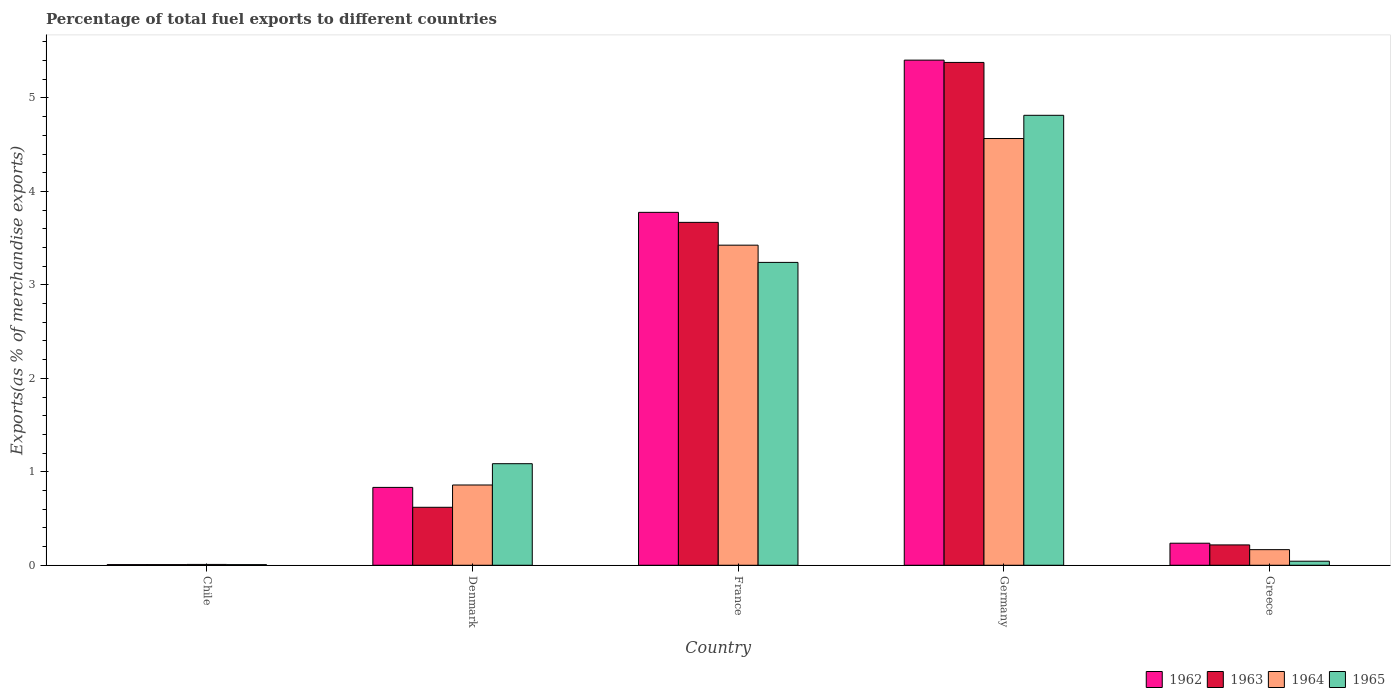Are the number of bars per tick equal to the number of legend labels?
Keep it short and to the point. Yes. Are the number of bars on each tick of the X-axis equal?
Your answer should be compact. Yes. How many bars are there on the 4th tick from the left?
Provide a short and direct response. 4. In how many cases, is the number of bars for a given country not equal to the number of legend labels?
Offer a very short reply. 0. What is the percentage of exports to different countries in 1965 in Germany?
Provide a short and direct response. 4.81. Across all countries, what is the maximum percentage of exports to different countries in 1962?
Provide a succinct answer. 5.4. Across all countries, what is the minimum percentage of exports to different countries in 1962?
Keep it short and to the point. 0.01. What is the total percentage of exports to different countries in 1962 in the graph?
Keep it short and to the point. 10.26. What is the difference between the percentage of exports to different countries in 1963 in Chile and that in Greece?
Make the answer very short. -0.21. What is the difference between the percentage of exports to different countries in 1962 in Chile and the percentage of exports to different countries in 1965 in Denmark?
Provide a succinct answer. -1.08. What is the average percentage of exports to different countries in 1965 per country?
Give a very brief answer. 1.84. What is the difference between the percentage of exports to different countries of/in 1963 and percentage of exports to different countries of/in 1962 in Greece?
Provide a short and direct response. -0.02. What is the ratio of the percentage of exports to different countries in 1963 in Denmark to that in Germany?
Give a very brief answer. 0.12. What is the difference between the highest and the second highest percentage of exports to different countries in 1963?
Your answer should be very brief. -3.05. What is the difference between the highest and the lowest percentage of exports to different countries in 1963?
Keep it short and to the point. 5.37. In how many countries, is the percentage of exports to different countries in 1964 greater than the average percentage of exports to different countries in 1964 taken over all countries?
Ensure brevity in your answer.  2. What does the 2nd bar from the left in Denmark represents?
Your response must be concise. 1963. What does the 2nd bar from the right in Denmark represents?
Your answer should be very brief. 1964. Is it the case that in every country, the sum of the percentage of exports to different countries in 1962 and percentage of exports to different countries in 1963 is greater than the percentage of exports to different countries in 1964?
Offer a very short reply. Yes. Are all the bars in the graph horizontal?
Your answer should be compact. No. How many countries are there in the graph?
Your answer should be compact. 5. What is the difference between two consecutive major ticks on the Y-axis?
Your response must be concise. 1. Does the graph contain any zero values?
Your answer should be very brief. No. Does the graph contain grids?
Give a very brief answer. No. What is the title of the graph?
Provide a succinct answer. Percentage of total fuel exports to different countries. What is the label or title of the X-axis?
Your response must be concise. Country. What is the label or title of the Y-axis?
Provide a succinct answer. Exports(as % of merchandise exports). What is the Exports(as % of merchandise exports) of 1962 in Chile?
Provide a succinct answer. 0.01. What is the Exports(as % of merchandise exports) of 1963 in Chile?
Make the answer very short. 0.01. What is the Exports(as % of merchandise exports) of 1964 in Chile?
Your answer should be compact. 0.01. What is the Exports(as % of merchandise exports) in 1965 in Chile?
Offer a terse response. 0.01. What is the Exports(as % of merchandise exports) in 1962 in Denmark?
Your response must be concise. 0.83. What is the Exports(as % of merchandise exports) in 1963 in Denmark?
Your answer should be compact. 0.62. What is the Exports(as % of merchandise exports) in 1964 in Denmark?
Offer a very short reply. 0.86. What is the Exports(as % of merchandise exports) of 1965 in Denmark?
Your answer should be very brief. 1.09. What is the Exports(as % of merchandise exports) in 1962 in France?
Your answer should be compact. 3.78. What is the Exports(as % of merchandise exports) in 1963 in France?
Your answer should be very brief. 3.67. What is the Exports(as % of merchandise exports) of 1964 in France?
Your answer should be compact. 3.43. What is the Exports(as % of merchandise exports) in 1965 in France?
Offer a very short reply. 3.24. What is the Exports(as % of merchandise exports) of 1962 in Germany?
Ensure brevity in your answer.  5.4. What is the Exports(as % of merchandise exports) in 1963 in Germany?
Provide a succinct answer. 5.38. What is the Exports(as % of merchandise exports) of 1964 in Germany?
Provide a succinct answer. 4.57. What is the Exports(as % of merchandise exports) of 1965 in Germany?
Your answer should be very brief. 4.81. What is the Exports(as % of merchandise exports) of 1962 in Greece?
Provide a short and direct response. 0.24. What is the Exports(as % of merchandise exports) in 1963 in Greece?
Offer a very short reply. 0.22. What is the Exports(as % of merchandise exports) in 1964 in Greece?
Your answer should be very brief. 0.17. What is the Exports(as % of merchandise exports) of 1965 in Greece?
Ensure brevity in your answer.  0.04. Across all countries, what is the maximum Exports(as % of merchandise exports) in 1962?
Your response must be concise. 5.4. Across all countries, what is the maximum Exports(as % of merchandise exports) of 1963?
Your response must be concise. 5.38. Across all countries, what is the maximum Exports(as % of merchandise exports) in 1964?
Offer a very short reply. 4.57. Across all countries, what is the maximum Exports(as % of merchandise exports) of 1965?
Your answer should be very brief. 4.81. Across all countries, what is the minimum Exports(as % of merchandise exports) of 1962?
Offer a terse response. 0.01. Across all countries, what is the minimum Exports(as % of merchandise exports) in 1963?
Your response must be concise. 0.01. Across all countries, what is the minimum Exports(as % of merchandise exports) in 1964?
Offer a terse response. 0.01. Across all countries, what is the minimum Exports(as % of merchandise exports) in 1965?
Offer a terse response. 0.01. What is the total Exports(as % of merchandise exports) of 1962 in the graph?
Offer a very short reply. 10.26. What is the total Exports(as % of merchandise exports) in 1963 in the graph?
Keep it short and to the point. 9.89. What is the total Exports(as % of merchandise exports) of 1964 in the graph?
Provide a short and direct response. 9.03. What is the total Exports(as % of merchandise exports) of 1965 in the graph?
Offer a terse response. 9.19. What is the difference between the Exports(as % of merchandise exports) of 1962 in Chile and that in Denmark?
Keep it short and to the point. -0.83. What is the difference between the Exports(as % of merchandise exports) in 1963 in Chile and that in Denmark?
Ensure brevity in your answer.  -0.61. What is the difference between the Exports(as % of merchandise exports) in 1964 in Chile and that in Denmark?
Keep it short and to the point. -0.85. What is the difference between the Exports(as % of merchandise exports) in 1965 in Chile and that in Denmark?
Make the answer very short. -1.08. What is the difference between the Exports(as % of merchandise exports) in 1962 in Chile and that in France?
Provide a succinct answer. -3.77. What is the difference between the Exports(as % of merchandise exports) in 1963 in Chile and that in France?
Provide a short and direct response. -3.66. What is the difference between the Exports(as % of merchandise exports) in 1964 in Chile and that in France?
Provide a succinct answer. -3.42. What is the difference between the Exports(as % of merchandise exports) in 1965 in Chile and that in France?
Your answer should be compact. -3.23. What is the difference between the Exports(as % of merchandise exports) of 1962 in Chile and that in Germany?
Keep it short and to the point. -5.4. What is the difference between the Exports(as % of merchandise exports) in 1963 in Chile and that in Germany?
Provide a succinct answer. -5.37. What is the difference between the Exports(as % of merchandise exports) of 1964 in Chile and that in Germany?
Offer a very short reply. -4.56. What is the difference between the Exports(as % of merchandise exports) of 1965 in Chile and that in Germany?
Your answer should be compact. -4.81. What is the difference between the Exports(as % of merchandise exports) of 1962 in Chile and that in Greece?
Your answer should be very brief. -0.23. What is the difference between the Exports(as % of merchandise exports) in 1963 in Chile and that in Greece?
Give a very brief answer. -0.21. What is the difference between the Exports(as % of merchandise exports) in 1964 in Chile and that in Greece?
Offer a very short reply. -0.16. What is the difference between the Exports(as % of merchandise exports) in 1965 in Chile and that in Greece?
Provide a short and direct response. -0.04. What is the difference between the Exports(as % of merchandise exports) of 1962 in Denmark and that in France?
Provide a succinct answer. -2.94. What is the difference between the Exports(as % of merchandise exports) of 1963 in Denmark and that in France?
Provide a succinct answer. -3.05. What is the difference between the Exports(as % of merchandise exports) in 1964 in Denmark and that in France?
Make the answer very short. -2.57. What is the difference between the Exports(as % of merchandise exports) of 1965 in Denmark and that in France?
Your response must be concise. -2.15. What is the difference between the Exports(as % of merchandise exports) in 1962 in Denmark and that in Germany?
Provide a short and direct response. -4.57. What is the difference between the Exports(as % of merchandise exports) of 1963 in Denmark and that in Germany?
Keep it short and to the point. -4.76. What is the difference between the Exports(as % of merchandise exports) of 1964 in Denmark and that in Germany?
Your answer should be very brief. -3.71. What is the difference between the Exports(as % of merchandise exports) in 1965 in Denmark and that in Germany?
Your response must be concise. -3.73. What is the difference between the Exports(as % of merchandise exports) in 1962 in Denmark and that in Greece?
Your answer should be compact. 0.6. What is the difference between the Exports(as % of merchandise exports) in 1963 in Denmark and that in Greece?
Give a very brief answer. 0.4. What is the difference between the Exports(as % of merchandise exports) in 1964 in Denmark and that in Greece?
Offer a very short reply. 0.69. What is the difference between the Exports(as % of merchandise exports) of 1965 in Denmark and that in Greece?
Make the answer very short. 1.04. What is the difference between the Exports(as % of merchandise exports) in 1962 in France and that in Germany?
Offer a very short reply. -1.63. What is the difference between the Exports(as % of merchandise exports) in 1963 in France and that in Germany?
Provide a short and direct response. -1.71. What is the difference between the Exports(as % of merchandise exports) in 1964 in France and that in Germany?
Your answer should be very brief. -1.14. What is the difference between the Exports(as % of merchandise exports) of 1965 in France and that in Germany?
Offer a very short reply. -1.57. What is the difference between the Exports(as % of merchandise exports) of 1962 in France and that in Greece?
Offer a very short reply. 3.54. What is the difference between the Exports(as % of merchandise exports) in 1963 in France and that in Greece?
Keep it short and to the point. 3.45. What is the difference between the Exports(as % of merchandise exports) in 1964 in France and that in Greece?
Give a very brief answer. 3.26. What is the difference between the Exports(as % of merchandise exports) in 1965 in France and that in Greece?
Provide a short and direct response. 3.2. What is the difference between the Exports(as % of merchandise exports) in 1962 in Germany and that in Greece?
Give a very brief answer. 5.17. What is the difference between the Exports(as % of merchandise exports) in 1963 in Germany and that in Greece?
Offer a very short reply. 5.16. What is the difference between the Exports(as % of merchandise exports) of 1964 in Germany and that in Greece?
Keep it short and to the point. 4.4. What is the difference between the Exports(as % of merchandise exports) of 1965 in Germany and that in Greece?
Offer a very short reply. 4.77. What is the difference between the Exports(as % of merchandise exports) of 1962 in Chile and the Exports(as % of merchandise exports) of 1963 in Denmark?
Your response must be concise. -0.61. What is the difference between the Exports(as % of merchandise exports) in 1962 in Chile and the Exports(as % of merchandise exports) in 1964 in Denmark?
Your answer should be very brief. -0.85. What is the difference between the Exports(as % of merchandise exports) of 1962 in Chile and the Exports(as % of merchandise exports) of 1965 in Denmark?
Provide a succinct answer. -1.08. What is the difference between the Exports(as % of merchandise exports) of 1963 in Chile and the Exports(as % of merchandise exports) of 1964 in Denmark?
Provide a short and direct response. -0.85. What is the difference between the Exports(as % of merchandise exports) in 1963 in Chile and the Exports(as % of merchandise exports) in 1965 in Denmark?
Provide a succinct answer. -1.08. What is the difference between the Exports(as % of merchandise exports) of 1964 in Chile and the Exports(as % of merchandise exports) of 1965 in Denmark?
Your answer should be very brief. -1.08. What is the difference between the Exports(as % of merchandise exports) of 1962 in Chile and the Exports(as % of merchandise exports) of 1963 in France?
Your answer should be very brief. -3.66. What is the difference between the Exports(as % of merchandise exports) of 1962 in Chile and the Exports(as % of merchandise exports) of 1964 in France?
Keep it short and to the point. -3.42. What is the difference between the Exports(as % of merchandise exports) of 1962 in Chile and the Exports(as % of merchandise exports) of 1965 in France?
Provide a short and direct response. -3.23. What is the difference between the Exports(as % of merchandise exports) of 1963 in Chile and the Exports(as % of merchandise exports) of 1964 in France?
Make the answer very short. -3.42. What is the difference between the Exports(as % of merchandise exports) in 1963 in Chile and the Exports(as % of merchandise exports) in 1965 in France?
Keep it short and to the point. -3.23. What is the difference between the Exports(as % of merchandise exports) in 1964 in Chile and the Exports(as % of merchandise exports) in 1965 in France?
Your answer should be compact. -3.23. What is the difference between the Exports(as % of merchandise exports) in 1962 in Chile and the Exports(as % of merchandise exports) in 1963 in Germany?
Your answer should be very brief. -5.37. What is the difference between the Exports(as % of merchandise exports) of 1962 in Chile and the Exports(as % of merchandise exports) of 1964 in Germany?
Make the answer very short. -4.56. What is the difference between the Exports(as % of merchandise exports) in 1962 in Chile and the Exports(as % of merchandise exports) in 1965 in Germany?
Give a very brief answer. -4.81. What is the difference between the Exports(as % of merchandise exports) of 1963 in Chile and the Exports(as % of merchandise exports) of 1964 in Germany?
Offer a terse response. -4.56. What is the difference between the Exports(as % of merchandise exports) in 1963 in Chile and the Exports(as % of merchandise exports) in 1965 in Germany?
Offer a terse response. -4.81. What is the difference between the Exports(as % of merchandise exports) in 1964 in Chile and the Exports(as % of merchandise exports) in 1965 in Germany?
Offer a very short reply. -4.81. What is the difference between the Exports(as % of merchandise exports) of 1962 in Chile and the Exports(as % of merchandise exports) of 1963 in Greece?
Your answer should be compact. -0.21. What is the difference between the Exports(as % of merchandise exports) of 1962 in Chile and the Exports(as % of merchandise exports) of 1964 in Greece?
Your answer should be very brief. -0.16. What is the difference between the Exports(as % of merchandise exports) in 1962 in Chile and the Exports(as % of merchandise exports) in 1965 in Greece?
Give a very brief answer. -0.04. What is the difference between the Exports(as % of merchandise exports) in 1963 in Chile and the Exports(as % of merchandise exports) in 1964 in Greece?
Provide a short and direct response. -0.16. What is the difference between the Exports(as % of merchandise exports) in 1963 in Chile and the Exports(as % of merchandise exports) in 1965 in Greece?
Offer a terse response. -0.04. What is the difference between the Exports(as % of merchandise exports) in 1964 in Chile and the Exports(as % of merchandise exports) in 1965 in Greece?
Offer a terse response. -0.03. What is the difference between the Exports(as % of merchandise exports) of 1962 in Denmark and the Exports(as % of merchandise exports) of 1963 in France?
Make the answer very short. -2.84. What is the difference between the Exports(as % of merchandise exports) of 1962 in Denmark and the Exports(as % of merchandise exports) of 1964 in France?
Offer a terse response. -2.59. What is the difference between the Exports(as % of merchandise exports) in 1962 in Denmark and the Exports(as % of merchandise exports) in 1965 in France?
Offer a very short reply. -2.41. What is the difference between the Exports(as % of merchandise exports) in 1963 in Denmark and the Exports(as % of merchandise exports) in 1964 in France?
Give a very brief answer. -2.8. What is the difference between the Exports(as % of merchandise exports) in 1963 in Denmark and the Exports(as % of merchandise exports) in 1965 in France?
Provide a short and direct response. -2.62. What is the difference between the Exports(as % of merchandise exports) of 1964 in Denmark and the Exports(as % of merchandise exports) of 1965 in France?
Offer a very short reply. -2.38. What is the difference between the Exports(as % of merchandise exports) in 1962 in Denmark and the Exports(as % of merchandise exports) in 1963 in Germany?
Provide a short and direct response. -4.55. What is the difference between the Exports(as % of merchandise exports) of 1962 in Denmark and the Exports(as % of merchandise exports) of 1964 in Germany?
Provide a short and direct response. -3.73. What is the difference between the Exports(as % of merchandise exports) of 1962 in Denmark and the Exports(as % of merchandise exports) of 1965 in Germany?
Keep it short and to the point. -3.98. What is the difference between the Exports(as % of merchandise exports) in 1963 in Denmark and the Exports(as % of merchandise exports) in 1964 in Germany?
Your response must be concise. -3.95. What is the difference between the Exports(as % of merchandise exports) of 1963 in Denmark and the Exports(as % of merchandise exports) of 1965 in Germany?
Give a very brief answer. -4.19. What is the difference between the Exports(as % of merchandise exports) of 1964 in Denmark and the Exports(as % of merchandise exports) of 1965 in Germany?
Your answer should be very brief. -3.96. What is the difference between the Exports(as % of merchandise exports) in 1962 in Denmark and the Exports(as % of merchandise exports) in 1963 in Greece?
Your answer should be compact. 0.62. What is the difference between the Exports(as % of merchandise exports) of 1962 in Denmark and the Exports(as % of merchandise exports) of 1964 in Greece?
Provide a succinct answer. 0.67. What is the difference between the Exports(as % of merchandise exports) in 1962 in Denmark and the Exports(as % of merchandise exports) in 1965 in Greece?
Offer a terse response. 0.79. What is the difference between the Exports(as % of merchandise exports) of 1963 in Denmark and the Exports(as % of merchandise exports) of 1964 in Greece?
Provide a succinct answer. 0.45. What is the difference between the Exports(as % of merchandise exports) of 1963 in Denmark and the Exports(as % of merchandise exports) of 1965 in Greece?
Offer a terse response. 0.58. What is the difference between the Exports(as % of merchandise exports) of 1964 in Denmark and the Exports(as % of merchandise exports) of 1965 in Greece?
Offer a very short reply. 0.82. What is the difference between the Exports(as % of merchandise exports) in 1962 in France and the Exports(as % of merchandise exports) in 1963 in Germany?
Provide a short and direct response. -1.6. What is the difference between the Exports(as % of merchandise exports) in 1962 in France and the Exports(as % of merchandise exports) in 1964 in Germany?
Keep it short and to the point. -0.79. What is the difference between the Exports(as % of merchandise exports) of 1962 in France and the Exports(as % of merchandise exports) of 1965 in Germany?
Keep it short and to the point. -1.04. What is the difference between the Exports(as % of merchandise exports) in 1963 in France and the Exports(as % of merchandise exports) in 1964 in Germany?
Offer a terse response. -0.9. What is the difference between the Exports(as % of merchandise exports) in 1963 in France and the Exports(as % of merchandise exports) in 1965 in Germany?
Make the answer very short. -1.15. What is the difference between the Exports(as % of merchandise exports) in 1964 in France and the Exports(as % of merchandise exports) in 1965 in Germany?
Give a very brief answer. -1.39. What is the difference between the Exports(as % of merchandise exports) in 1962 in France and the Exports(as % of merchandise exports) in 1963 in Greece?
Give a very brief answer. 3.56. What is the difference between the Exports(as % of merchandise exports) in 1962 in France and the Exports(as % of merchandise exports) in 1964 in Greece?
Ensure brevity in your answer.  3.61. What is the difference between the Exports(as % of merchandise exports) in 1962 in France and the Exports(as % of merchandise exports) in 1965 in Greece?
Give a very brief answer. 3.73. What is the difference between the Exports(as % of merchandise exports) of 1963 in France and the Exports(as % of merchandise exports) of 1964 in Greece?
Provide a short and direct response. 3.5. What is the difference between the Exports(as % of merchandise exports) of 1963 in France and the Exports(as % of merchandise exports) of 1965 in Greece?
Make the answer very short. 3.63. What is the difference between the Exports(as % of merchandise exports) in 1964 in France and the Exports(as % of merchandise exports) in 1965 in Greece?
Provide a short and direct response. 3.38. What is the difference between the Exports(as % of merchandise exports) in 1962 in Germany and the Exports(as % of merchandise exports) in 1963 in Greece?
Provide a short and direct response. 5.19. What is the difference between the Exports(as % of merchandise exports) in 1962 in Germany and the Exports(as % of merchandise exports) in 1964 in Greece?
Make the answer very short. 5.24. What is the difference between the Exports(as % of merchandise exports) of 1962 in Germany and the Exports(as % of merchandise exports) of 1965 in Greece?
Ensure brevity in your answer.  5.36. What is the difference between the Exports(as % of merchandise exports) in 1963 in Germany and the Exports(as % of merchandise exports) in 1964 in Greece?
Your answer should be compact. 5.21. What is the difference between the Exports(as % of merchandise exports) in 1963 in Germany and the Exports(as % of merchandise exports) in 1965 in Greece?
Provide a succinct answer. 5.34. What is the difference between the Exports(as % of merchandise exports) in 1964 in Germany and the Exports(as % of merchandise exports) in 1965 in Greece?
Provide a short and direct response. 4.52. What is the average Exports(as % of merchandise exports) of 1962 per country?
Your answer should be compact. 2.05. What is the average Exports(as % of merchandise exports) of 1963 per country?
Offer a terse response. 1.98. What is the average Exports(as % of merchandise exports) in 1964 per country?
Give a very brief answer. 1.81. What is the average Exports(as % of merchandise exports) in 1965 per country?
Your answer should be very brief. 1.84. What is the difference between the Exports(as % of merchandise exports) of 1962 and Exports(as % of merchandise exports) of 1963 in Chile?
Keep it short and to the point. -0. What is the difference between the Exports(as % of merchandise exports) of 1962 and Exports(as % of merchandise exports) of 1964 in Chile?
Provide a succinct answer. -0. What is the difference between the Exports(as % of merchandise exports) in 1962 and Exports(as % of merchandise exports) in 1965 in Chile?
Make the answer very short. 0. What is the difference between the Exports(as % of merchandise exports) in 1963 and Exports(as % of merchandise exports) in 1964 in Chile?
Your response must be concise. -0. What is the difference between the Exports(as % of merchandise exports) of 1964 and Exports(as % of merchandise exports) of 1965 in Chile?
Provide a succinct answer. 0. What is the difference between the Exports(as % of merchandise exports) in 1962 and Exports(as % of merchandise exports) in 1963 in Denmark?
Make the answer very short. 0.21. What is the difference between the Exports(as % of merchandise exports) of 1962 and Exports(as % of merchandise exports) of 1964 in Denmark?
Give a very brief answer. -0.03. What is the difference between the Exports(as % of merchandise exports) of 1962 and Exports(as % of merchandise exports) of 1965 in Denmark?
Your answer should be very brief. -0.25. What is the difference between the Exports(as % of merchandise exports) of 1963 and Exports(as % of merchandise exports) of 1964 in Denmark?
Offer a terse response. -0.24. What is the difference between the Exports(as % of merchandise exports) of 1963 and Exports(as % of merchandise exports) of 1965 in Denmark?
Ensure brevity in your answer.  -0.47. What is the difference between the Exports(as % of merchandise exports) of 1964 and Exports(as % of merchandise exports) of 1965 in Denmark?
Your answer should be compact. -0.23. What is the difference between the Exports(as % of merchandise exports) in 1962 and Exports(as % of merchandise exports) in 1963 in France?
Offer a terse response. 0.11. What is the difference between the Exports(as % of merchandise exports) of 1962 and Exports(as % of merchandise exports) of 1964 in France?
Your answer should be compact. 0.35. What is the difference between the Exports(as % of merchandise exports) in 1962 and Exports(as % of merchandise exports) in 1965 in France?
Make the answer very short. 0.54. What is the difference between the Exports(as % of merchandise exports) in 1963 and Exports(as % of merchandise exports) in 1964 in France?
Make the answer very short. 0.24. What is the difference between the Exports(as % of merchandise exports) of 1963 and Exports(as % of merchandise exports) of 1965 in France?
Provide a short and direct response. 0.43. What is the difference between the Exports(as % of merchandise exports) in 1964 and Exports(as % of merchandise exports) in 1965 in France?
Offer a very short reply. 0.18. What is the difference between the Exports(as % of merchandise exports) in 1962 and Exports(as % of merchandise exports) in 1963 in Germany?
Your response must be concise. 0.02. What is the difference between the Exports(as % of merchandise exports) of 1962 and Exports(as % of merchandise exports) of 1964 in Germany?
Make the answer very short. 0.84. What is the difference between the Exports(as % of merchandise exports) in 1962 and Exports(as % of merchandise exports) in 1965 in Germany?
Offer a very short reply. 0.59. What is the difference between the Exports(as % of merchandise exports) of 1963 and Exports(as % of merchandise exports) of 1964 in Germany?
Ensure brevity in your answer.  0.81. What is the difference between the Exports(as % of merchandise exports) in 1963 and Exports(as % of merchandise exports) in 1965 in Germany?
Offer a terse response. 0.57. What is the difference between the Exports(as % of merchandise exports) in 1964 and Exports(as % of merchandise exports) in 1965 in Germany?
Your response must be concise. -0.25. What is the difference between the Exports(as % of merchandise exports) of 1962 and Exports(as % of merchandise exports) of 1963 in Greece?
Your answer should be compact. 0.02. What is the difference between the Exports(as % of merchandise exports) in 1962 and Exports(as % of merchandise exports) in 1964 in Greece?
Offer a terse response. 0.07. What is the difference between the Exports(as % of merchandise exports) in 1962 and Exports(as % of merchandise exports) in 1965 in Greece?
Give a very brief answer. 0.19. What is the difference between the Exports(as % of merchandise exports) of 1963 and Exports(as % of merchandise exports) of 1964 in Greece?
Make the answer very short. 0.05. What is the difference between the Exports(as % of merchandise exports) of 1963 and Exports(as % of merchandise exports) of 1965 in Greece?
Ensure brevity in your answer.  0.17. What is the difference between the Exports(as % of merchandise exports) of 1964 and Exports(as % of merchandise exports) of 1965 in Greece?
Make the answer very short. 0.12. What is the ratio of the Exports(as % of merchandise exports) in 1962 in Chile to that in Denmark?
Make the answer very short. 0.01. What is the ratio of the Exports(as % of merchandise exports) in 1963 in Chile to that in Denmark?
Ensure brevity in your answer.  0.01. What is the ratio of the Exports(as % of merchandise exports) in 1964 in Chile to that in Denmark?
Provide a succinct answer. 0.01. What is the ratio of the Exports(as % of merchandise exports) in 1965 in Chile to that in Denmark?
Provide a short and direct response. 0.01. What is the ratio of the Exports(as % of merchandise exports) in 1962 in Chile to that in France?
Your answer should be compact. 0. What is the ratio of the Exports(as % of merchandise exports) of 1963 in Chile to that in France?
Your answer should be very brief. 0. What is the ratio of the Exports(as % of merchandise exports) of 1964 in Chile to that in France?
Provide a succinct answer. 0. What is the ratio of the Exports(as % of merchandise exports) in 1965 in Chile to that in France?
Your answer should be compact. 0. What is the ratio of the Exports(as % of merchandise exports) of 1962 in Chile to that in Germany?
Provide a succinct answer. 0. What is the ratio of the Exports(as % of merchandise exports) in 1963 in Chile to that in Germany?
Provide a short and direct response. 0. What is the ratio of the Exports(as % of merchandise exports) in 1964 in Chile to that in Germany?
Your answer should be compact. 0. What is the ratio of the Exports(as % of merchandise exports) in 1965 in Chile to that in Germany?
Ensure brevity in your answer.  0. What is the ratio of the Exports(as % of merchandise exports) of 1962 in Chile to that in Greece?
Your response must be concise. 0.03. What is the ratio of the Exports(as % of merchandise exports) of 1963 in Chile to that in Greece?
Provide a succinct answer. 0.03. What is the ratio of the Exports(as % of merchandise exports) in 1964 in Chile to that in Greece?
Make the answer very short. 0.05. What is the ratio of the Exports(as % of merchandise exports) in 1965 in Chile to that in Greece?
Offer a terse response. 0.16. What is the ratio of the Exports(as % of merchandise exports) in 1962 in Denmark to that in France?
Provide a succinct answer. 0.22. What is the ratio of the Exports(as % of merchandise exports) of 1963 in Denmark to that in France?
Ensure brevity in your answer.  0.17. What is the ratio of the Exports(as % of merchandise exports) in 1964 in Denmark to that in France?
Offer a very short reply. 0.25. What is the ratio of the Exports(as % of merchandise exports) of 1965 in Denmark to that in France?
Your answer should be compact. 0.34. What is the ratio of the Exports(as % of merchandise exports) in 1962 in Denmark to that in Germany?
Offer a terse response. 0.15. What is the ratio of the Exports(as % of merchandise exports) of 1963 in Denmark to that in Germany?
Provide a succinct answer. 0.12. What is the ratio of the Exports(as % of merchandise exports) of 1964 in Denmark to that in Germany?
Make the answer very short. 0.19. What is the ratio of the Exports(as % of merchandise exports) of 1965 in Denmark to that in Germany?
Make the answer very short. 0.23. What is the ratio of the Exports(as % of merchandise exports) in 1962 in Denmark to that in Greece?
Give a very brief answer. 3.53. What is the ratio of the Exports(as % of merchandise exports) of 1963 in Denmark to that in Greece?
Make the answer very short. 2.85. What is the ratio of the Exports(as % of merchandise exports) of 1964 in Denmark to that in Greece?
Give a very brief answer. 5.14. What is the ratio of the Exports(as % of merchandise exports) of 1965 in Denmark to that in Greece?
Give a very brief answer. 25.05. What is the ratio of the Exports(as % of merchandise exports) in 1962 in France to that in Germany?
Give a very brief answer. 0.7. What is the ratio of the Exports(as % of merchandise exports) in 1963 in France to that in Germany?
Give a very brief answer. 0.68. What is the ratio of the Exports(as % of merchandise exports) of 1964 in France to that in Germany?
Offer a terse response. 0.75. What is the ratio of the Exports(as % of merchandise exports) in 1965 in France to that in Germany?
Your response must be concise. 0.67. What is the ratio of the Exports(as % of merchandise exports) in 1962 in France to that in Greece?
Your response must be concise. 16.01. What is the ratio of the Exports(as % of merchandise exports) of 1963 in France to that in Greece?
Offer a very short reply. 16.85. What is the ratio of the Exports(as % of merchandise exports) of 1964 in France to that in Greece?
Make the answer very short. 20.5. What is the ratio of the Exports(as % of merchandise exports) of 1965 in France to that in Greece?
Ensure brevity in your answer.  74.69. What is the ratio of the Exports(as % of merchandise exports) in 1962 in Germany to that in Greece?
Your response must be concise. 22.91. What is the ratio of the Exports(as % of merchandise exports) of 1963 in Germany to that in Greece?
Offer a terse response. 24.71. What is the ratio of the Exports(as % of merchandise exports) of 1964 in Germany to that in Greece?
Offer a very short reply. 27.34. What is the ratio of the Exports(as % of merchandise exports) in 1965 in Germany to that in Greece?
Keep it short and to the point. 110.96. What is the difference between the highest and the second highest Exports(as % of merchandise exports) in 1962?
Your answer should be compact. 1.63. What is the difference between the highest and the second highest Exports(as % of merchandise exports) of 1963?
Offer a terse response. 1.71. What is the difference between the highest and the second highest Exports(as % of merchandise exports) of 1964?
Your answer should be compact. 1.14. What is the difference between the highest and the second highest Exports(as % of merchandise exports) of 1965?
Provide a succinct answer. 1.57. What is the difference between the highest and the lowest Exports(as % of merchandise exports) in 1962?
Offer a terse response. 5.4. What is the difference between the highest and the lowest Exports(as % of merchandise exports) in 1963?
Offer a very short reply. 5.37. What is the difference between the highest and the lowest Exports(as % of merchandise exports) in 1964?
Keep it short and to the point. 4.56. What is the difference between the highest and the lowest Exports(as % of merchandise exports) in 1965?
Offer a very short reply. 4.81. 